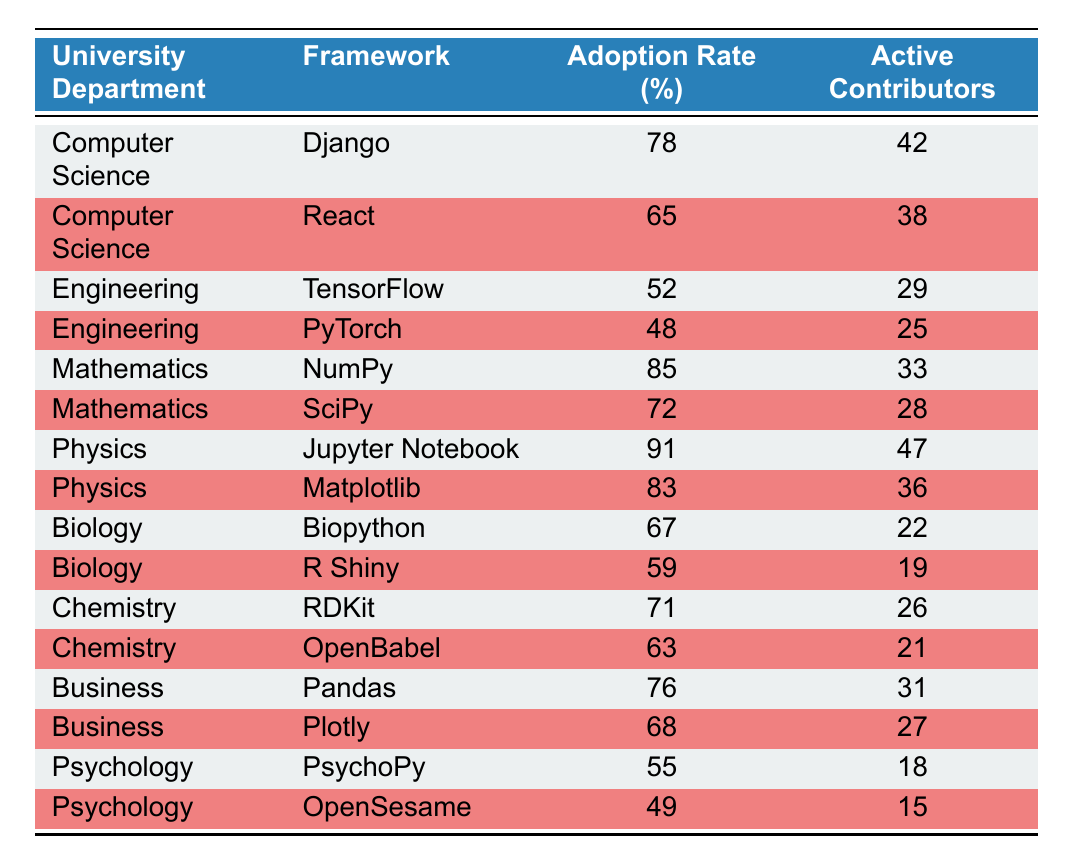What is the adoption rate of Jupyter Notebook in the Physics department? According to the table, the adoption rate for Jupyter Notebook under the Physics department is directly listed as 91%.
Answer: 91% Which department has the highest adoption rate for an open-source framework? Looking at the table, the highest adoption rate is for Physics with Jupyter Notebook at 91%.
Answer: Physics What is the difference in adoption rates between NumPy and SciPy? NumPy has an adoption rate of 85% while SciPy has an adoption rate of 72%. The difference is 85% - 72% = 13%.
Answer: 13% Is there a framework in the Biology department with an adoption rate lower than 60%? In the Biology department, both frameworks Biopython (67%) and R Shiny (59%) are present, but R Shiny has an adoption rate of 59%, which is lower than 60%. Thus the answer is yes.
Answer: Yes What is the average adoption rate for frameworks in the Engineering department? The adoption rates for Engineering frameworks are TensorFlow (52%) and PyTorch (48%). Adding these gives 52% + 48% = 100%. Dividing by the number of frameworks (2) gives an average of 100% / 2 = 50%.
Answer: 50% What are the total active contributors for the frameworks in the Mathematics department? For the Mathematics department, NumPy has 33 active contributors and SciPy has 28 active contributors. Summing these gives 33 + 28 = 61 active contributors in total for the Mathematics department.
Answer: 61 Which department has more active contributors, Computer Science or Psychology? The Computer Science department has 42 contributors for Django and 38 for React, totaling 80 active contributors. The Psychology department has 18 from PsychoPy and 15 from OpenSesame, totaling 33. Since 80 > 33, Computer Science has more contributors.
Answer: Computer Science Is the adoption rate for OpenBabel higher than the adoption rate for R Shiny? OpenBabel has an adoption rate of 63%, and R Shiny has an adoption rate of 59%. Since 63% > 59%, the statement is true.
Answer: Yes 